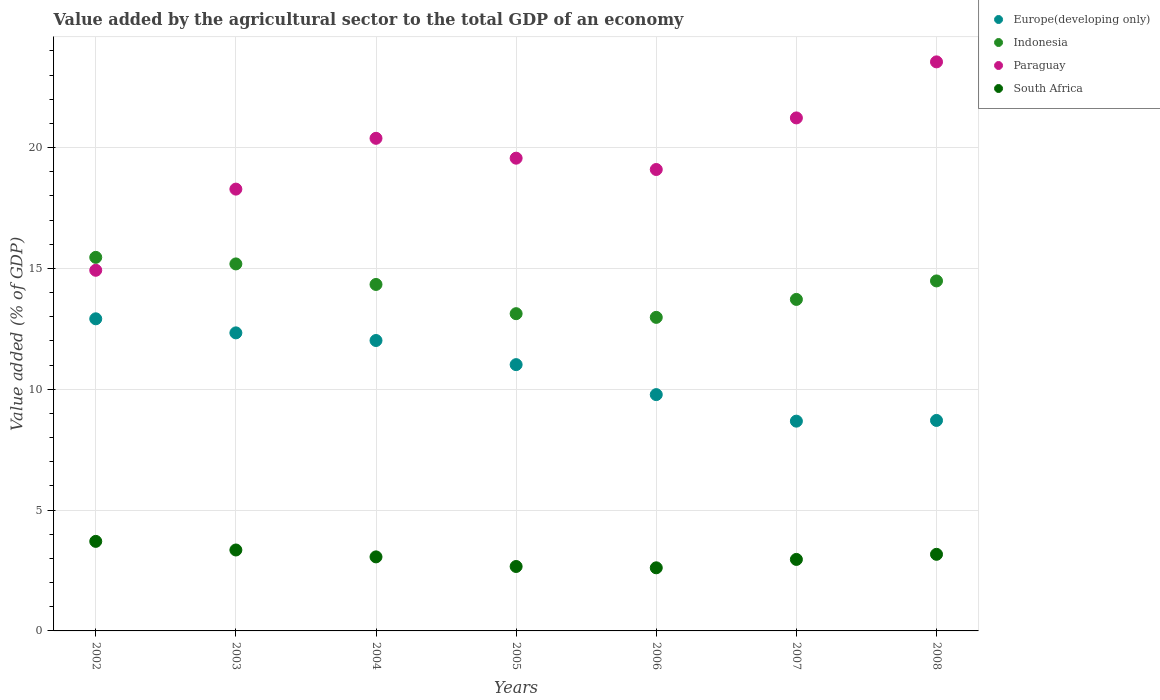How many different coloured dotlines are there?
Give a very brief answer. 4. Is the number of dotlines equal to the number of legend labels?
Your answer should be compact. Yes. What is the value added by the agricultural sector to the total GDP in Europe(developing only) in 2005?
Your answer should be compact. 11.02. Across all years, what is the maximum value added by the agricultural sector to the total GDP in South Africa?
Provide a short and direct response. 3.71. Across all years, what is the minimum value added by the agricultural sector to the total GDP in Paraguay?
Provide a short and direct response. 14.92. What is the total value added by the agricultural sector to the total GDP in Paraguay in the graph?
Your response must be concise. 137.01. What is the difference between the value added by the agricultural sector to the total GDP in Europe(developing only) in 2005 and that in 2006?
Offer a very short reply. 1.24. What is the difference between the value added by the agricultural sector to the total GDP in Indonesia in 2005 and the value added by the agricultural sector to the total GDP in Paraguay in 2008?
Your answer should be compact. -10.42. What is the average value added by the agricultural sector to the total GDP in Europe(developing only) per year?
Your answer should be very brief. 10.78. In the year 2007, what is the difference between the value added by the agricultural sector to the total GDP in South Africa and value added by the agricultural sector to the total GDP in Paraguay?
Your answer should be compact. -18.27. What is the ratio of the value added by the agricultural sector to the total GDP in South Africa in 2004 to that in 2005?
Your response must be concise. 1.15. Is the difference between the value added by the agricultural sector to the total GDP in South Africa in 2006 and 2007 greater than the difference between the value added by the agricultural sector to the total GDP in Paraguay in 2006 and 2007?
Keep it short and to the point. Yes. What is the difference between the highest and the second highest value added by the agricultural sector to the total GDP in Indonesia?
Make the answer very short. 0.27. What is the difference between the highest and the lowest value added by the agricultural sector to the total GDP in Europe(developing only)?
Provide a succinct answer. 4.23. In how many years, is the value added by the agricultural sector to the total GDP in Paraguay greater than the average value added by the agricultural sector to the total GDP in Paraguay taken over all years?
Your answer should be very brief. 3. Is it the case that in every year, the sum of the value added by the agricultural sector to the total GDP in South Africa and value added by the agricultural sector to the total GDP in Indonesia  is greater than the sum of value added by the agricultural sector to the total GDP in Europe(developing only) and value added by the agricultural sector to the total GDP in Paraguay?
Your answer should be very brief. No. Is it the case that in every year, the sum of the value added by the agricultural sector to the total GDP in Europe(developing only) and value added by the agricultural sector to the total GDP in Indonesia  is greater than the value added by the agricultural sector to the total GDP in South Africa?
Your response must be concise. Yes. Does the value added by the agricultural sector to the total GDP in South Africa monotonically increase over the years?
Offer a very short reply. No. Is the value added by the agricultural sector to the total GDP in South Africa strictly greater than the value added by the agricultural sector to the total GDP in Indonesia over the years?
Ensure brevity in your answer.  No. How many dotlines are there?
Your answer should be very brief. 4. What is the difference between two consecutive major ticks on the Y-axis?
Make the answer very short. 5. Where does the legend appear in the graph?
Keep it short and to the point. Top right. How are the legend labels stacked?
Your answer should be very brief. Vertical. What is the title of the graph?
Give a very brief answer. Value added by the agricultural sector to the total GDP of an economy. What is the label or title of the Y-axis?
Ensure brevity in your answer.  Value added (% of GDP). What is the Value added (% of GDP) in Europe(developing only) in 2002?
Provide a short and direct response. 12.91. What is the Value added (% of GDP) of Indonesia in 2002?
Offer a very short reply. 15.46. What is the Value added (% of GDP) in Paraguay in 2002?
Provide a succinct answer. 14.92. What is the Value added (% of GDP) of South Africa in 2002?
Keep it short and to the point. 3.71. What is the Value added (% of GDP) of Europe(developing only) in 2003?
Offer a terse response. 12.33. What is the Value added (% of GDP) of Indonesia in 2003?
Offer a terse response. 15.19. What is the Value added (% of GDP) of Paraguay in 2003?
Ensure brevity in your answer.  18.28. What is the Value added (% of GDP) in South Africa in 2003?
Ensure brevity in your answer.  3.35. What is the Value added (% of GDP) in Europe(developing only) in 2004?
Provide a succinct answer. 12.02. What is the Value added (% of GDP) of Indonesia in 2004?
Provide a short and direct response. 14.34. What is the Value added (% of GDP) in Paraguay in 2004?
Provide a succinct answer. 20.38. What is the Value added (% of GDP) in South Africa in 2004?
Make the answer very short. 3.06. What is the Value added (% of GDP) in Europe(developing only) in 2005?
Give a very brief answer. 11.02. What is the Value added (% of GDP) of Indonesia in 2005?
Offer a very short reply. 13.13. What is the Value added (% of GDP) in Paraguay in 2005?
Your response must be concise. 19.56. What is the Value added (% of GDP) in South Africa in 2005?
Provide a succinct answer. 2.67. What is the Value added (% of GDP) of Europe(developing only) in 2006?
Provide a succinct answer. 9.78. What is the Value added (% of GDP) in Indonesia in 2006?
Your response must be concise. 12.97. What is the Value added (% of GDP) in Paraguay in 2006?
Provide a succinct answer. 19.09. What is the Value added (% of GDP) of South Africa in 2006?
Offer a very short reply. 2.61. What is the Value added (% of GDP) of Europe(developing only) in 2007?
Keep it short and to the point. 8.68. What is the Value added (% of GDP) in Indonesia in 2007?
Your answer should be very brief. 13.72. What is the Value added (% of GDP) in Paraguay in 2007?
Provide a succinct answer. 21.23. What is the Value added (% of GDP) of South Africa in 2007?
Provide a succinct answer. 2.96. What is the Value added (% of GDP) in Europe(developing only) in 2008?
Offer a terse response. 8.71. What is the Value added (% of GDP) in Indonesia in 2008?
Your answer should be very brief. 14.48. What is the Value added (% of GDP) of Paraguay in 2008?
Ensure brevity in your answer.  23.55. What is the Value added (% of GDP) of South Africa in 2008?
Provide a short and direct response. 3.17. Across all years, what is the maximum Value added (% of GDP) of Europe(developing only)?
Make the answer very short. 12.91. Across all years, what is the maximum Value added (% of GDP) of Indonesia?
Offer a terse response. 15.46. Across all years, what is the maximum Value added (% of GDP) in Paraguay?
Offer a terse response. 23.55. Across all years, what is the maximum Value added (% of GDP) in South Africa?
Your answer should be very brief. 3.71. Across all years, what is the minimum Value added (% of GDP) of Europe(developing only)?
Give a very brief answer. 8.68. Across all years, what is the minimum Value added (% of GDP) in Indonesia?
Your answer should be very brief. 12.97. Across all years, what is the minimum Value added (% of GDP) of Paraguay?
Keep it short and to the point. 14.92. Across all years, what is the minimum Value added (% of GDP) of South Africa?
Provide a succinct answer. 2.61. What is the total Value added (% of GDP) of Europe(developing only) in the graph?
Keep it short and to the point. 75.45. What is the total Value added (% of GDP) in Indonesia in the graph?
Your answer should be compact. 99.28. What is the total Value added (% of GDP) of Paraguay in the graph?
Provide a succinct answer. 137.01. What is the total Value added (% of GDP) in South Africa in the graph?
Offer a terse response. 21.52. What is the difference between the Value added (% of GDP) of Europe(developing only) in 2002 and that in 2003?
Your answer should be very brief. 0.58. What is the difference between the Value added (% of GDP) of Indonesia in 2002 and that in 2003?
Your answer should be compact. 0.27. What is the difference between the Value added (% of GDP) of Paraguay in 2002 and that in 2003?
Your response must be concise. -3.36. What is the difference between the Value added (% of GDP) in South Africa in 2002 and that in 2003?
Keep it short and to the point. 0.36. What is the difference between the Value added (% of GDP) in Europe(developing only) in 2002 and that in 2004?
Offer a very short reply. 0.9. What is the difference between the Value added (% of GDP) in Indonesia in 2002 and that in 2004?
Provide a short and direct response. 1.12. What is the difference between the Value added (% of GDP) of Paraguay in 2002 and that in 2004?
Make the answer very short. -5.46. What is the difference between the Value added (% of GDP) of South Africa in 2002 and that in 2004?
Offer a terse response. 0.64. What is the difference between the Value added (% of GDP) of Europe(developing only) in 2002 and that in 2005?
Provide a short and direct response. 1.9. What is the difference between the Value added (% of GDP) of Indonesia in 2002 and that in 2005?
Your answer should be very brief. 2.33. What is the difference between the Value added (% of GDP) in Paraguay in 2002 and that in 2005?
Offer a terse response. -4.64. What is the difference between the Value added (% of GDP) of South Africa in 2002 and that in 2005?
Ensure brevity in your answer.  1.04. What is the difference between the Value added (% of GDP) of Europe(developing only) in 2002 and that in 2006?
Make the answer very short. 3.14. What is the difference between the Value added (% of GDP) of Indonesia in 2002 and that in 2006?
Give a very brief answer. 2.48. What is the difference between the Value added (% of GDP) of Paraguay in 2002 and that in 2006?
Offer a terse response. -4.17. What is the difference between the Value added (% of GDP) of South Africa in 2002 and that in 2006?
Keep it short and to the point. 1.09. What is the difference between the Value added (% of GDP) in Europe(developing only) in 2002 and that in 2007?
Offer a terse response. 4.23. What is the difference between the Value added (% of GDP) in Indonesia in 2002 and that in 2007?
Offer a terse response. 1.74. What is the difference between the Value added (% of GDP) of Paraguay in 2002 and that in 2007?
Your response must be concise. -6.3. What is the difference between the Value added (% of GDP) of South Africa in 2002 and that in 2007?
Keep it short and to the point. 0.75. What is the difference between the Value added (% of GDP) of Europe(developing only) in 2002 and that in 2008?
Provide a short and direct response. 4.21. What is the difference between the Value added (% of GDP) of Indonesia in 2002 and that in 2008?
Offer a terse response. 0.97. What is the difference between the Value added (% of GDP) in Paraguay in 2002 and that in 2008?
Your response must be concise. -8.62. What is the difference between the Value added (% of GDP) in South Africa in 2002 and that in 2008?
Ensure brevity in your answer.  0.54. What is the difference between the Value added (% of GDP) in Europe(developing only) in 2003 and that in 2004?
Your answer should be compact. 0.32. What is the difference between the Value added (% of GDP) in Indonesia in 2003 and that in 2004?
Ensure brevity in your answer.  0.85. What is the difference between the Value added (% of GDP) in Paraguay in 2003 and that in 2004?
Make the answer very short. -2.1. What is the difference between the Value added (% of GDP) of South Africa in 2003 and that in 2004?
Offer a terse response. 0.29. What is the difference between the Value added (% of GDP) of Europe(developing only) in 2003 and that in 2005?
Offer a terse response. 1.31. What is the difference between the Value added (% of GDP) in Indonesia in 2003 and that in 2005?
Provide a short and direct response. 2.06. What is the difference between the Value added (% of GDP) of Paraguay in 2003 and that in 2005?
Provide a succinct answer. -1.28. What is the difference between the Value added (% of GDP) in South Africa in 2003 and that in 2005?
Ensure brevity in your answer.  0.68. What is the difference between the Value added (% of GDP) of Europe(developing only) in 2003 and that in 2006?
Your answer should be very brief. 2.55. What is the difference between the Value added (% of GDP) of Indonesia in 2003 and that in 2006?
Your response must be concise. 2.21. What is the difference between the Value added (% of GDP) of Paraguay in 2003 and that in 2006?
Offer a very short reply. -0.81. What is the difference between the Value added (% of GDP) of South Africa in 2003 and that in 2006?
Make the answer very short. 0.74. What is the difference between the Value added (% of GDP) in Europe(developing only) in 2003 and that in 2007?
Offer a very short reply. 3.65. What is the difference between the Value added (% of GDP) of Indonesia in 2003 and that in 2007?
Your answer should be compact. 1.47. What is the difference between the Value added (% of GDP) of Paraguay in 2003 and that in 2007?
Your answer should be very brief. -2.95. What is the difference between the Value added (% of GDP) in South Africa in 2003 and that in 2007?
Make the answer very short. 0.39. What is the difference between the Value added (% of GDP) of Europe(developing only) in 2003 and that in 2008?
Your answer should be very brief. 3.62. What is the difference between the Value added (% of GDP) in Indonesia in 2003 and that in 2008?
Provide a short and direct response. 0.7. What is the difference between the Value added (% of GDP) of Paraguay in 2003 and that in 2008?
Provide a succinct answer. -5.26. What is the difference between the Value added (% of GDP) of South Africa in 2003 and that in 2008?
Ensure brevity in your answer.  0.18. What is the difference between the Value added (% of GDP) of Europe(developing only) in 2004 and that in 2005?
Provide a succinct answer. 1. What is the difference between the Value added (% of GDP) of Indonesia in 2004 and that in 2005?
Offer a very short reply. 1.21. What is the difference between the Value added (% of GDP) in Paraguay in 2004 and that in 2005?
Offer a terse response. 0.82. What is the difference between the Value added (% of GDP) of South Africa in 2004 and that in 2005?
Your answer should be compact. 0.4. What is the difference between the Value added (% of GDP) of Europe(developing only) in 2004 and that in 2006?
Your response must be concise. 2.24. What is the difference between the Value added (% of GDP) in Indonesia in 2004 and that in 2006?
Provide a succinct answer. 1.36. What is the difference between the Value added (% of GDP) in Paraguay in 2004 and that in 2006?
Your answer should be compact. 1.29. What is the difference between the Value added (% of GDP) in South Africa in 2004 and that in 2006?
Your response must be concise. 0.45. What is the difference between the Value added (% of GDP) of Europe(developing only) in 2004 and that in 2007?
Offer a terse response. 3.34. What is the difference between the Value added (% of GDP) of Indonesia in 2004 and that in 2007?
Give a very brief answer. 0.62. What is the difference between the Value added (% of GDP) in Paraguay in 2004 and that in 2007?
Keep it short and to the point. -0.84. What is the difference between the Value added (% of GDP) in South Africa in 2004 and that in 2007?
Make the answer very short. 0.1. What is the difference between the Value added (% of GDP) of Europe(developing only) in 2004 and that in 2008?
Your response must be concise. 3.31. What is the difference between the Value added (% of GDP) of Indonesia in 2004 and that in 2008?
Offer a terse response. -0.15. What is the difference between the Value added (% of GDP) of Paraguay in 2004 and that in 2008?
Your answer should be very brief. -3.16. What is the difference between the Value added (% of GDP) in South Africa in 2004 and that in 2008?
Make the answer very short. -0.11. What is the difference between the Value added (% of GDP) of Europe(developing only) in 2005 and that in 2006?
Your response must be concise. 1.24. What is the difference between the Value added (% of GDP) of Indonesia in 2005 and that in 2006?
Your answer should be compact. 0.15. What is the difference between the Value added (% of GDP) in Paraguay in 2005 and that in 2006?
Offer a very short reply. 0.47. What is the difference between the Value added (% of GDP) in South Africa in 2005 and that in 2006?
Offer a terse response. 0.05. What is the difference between the Value added (% of GDP) of Europe(developing only) in 2005 and that in 2007?
Ensure brevity in your answer.  2.34. What is the difference between the Value added (% of GDP) in Indonesia in 2005 and that in 2007?
Offer a terse response. -0.59. What is the difference between the Value added (% of GDP) of Paraguay in 2005 and that in 2007?
Make the answer very short. -1.67. What is the difference between the Value added (% of GDP) in South Africa in 2005 and that in 2007?
Make the answer very short. -0.29. What is the difference between the Value added (% of GDP) in Europe(developing only) in 2005 and that in 2008?
Provide a short and direct response. 2.31. What is the difference between the Value added (% of GDP) of Indonesia in 2005 and that in 2008?
Ensure brevity in your answer.  -1.36. What is the difference between the Value added (% of GDP) of Paraguay in 2005 and that in 2008?
Your answer should be very brief. -3.99. What is the difference between the Value added (% of GDP) in South Africa in 2005 and that in 2008?
Give a very brief answer. -0.5. What is the difference between the Value added (% of GDP) of Europe(developing only) in 2006 and that in 2007?
Offer a terse response. 1.1. What is the difference between the Value added (% of GDP) in Indonesia in 2006 and that in 2007?
Your answer should be compact. -0.74. What is the difference between the Value added (% of GDP) in Paraguay in 2006 and that in 2007?
Give a very brief answer. -2.13. What is the difference between the Value added (% of GDP) of South Africa in 2006 and that in 2007?
Offer a terse response. -0.35. What is the difference between the Value added (% of GDP) in Europe(developing only) in 2006 and that in 2008?
Offer a very short reply. 1.07. What is the difference between the Value added (% of GDP) of Indonesia in 2006 and that in 2008?
Keep it short and to the point. -1.51. What is the difference between the Value added (% of GDP) of Paraguay in 2006 and that in 2008?
Provide a short and direct response. -4.45. What is the difference between the Value added (% of GDP) in South Africa in 2006 and that in 2008?
Provide a short and direct response. -0.56. What is the difference between the Value added (% of GDP) of Europe(developing only) in 2007 and that in 2008?
Offer a very short reply. -0.03. What is the difference between the Value added (% of GDP) of Indonesia in 2007 and that in 2008?
Make the answer very short. -0.77. What is the difference between the Value added (% of GDP) of Paraguay in 2007 and that in 2008?
Provide a succinct answer. -2.32. What is the difference between the Value added (% of GDP) of South Africa in 2007 and that in 2008?
Offer a very short reply. -0.21. What is the difference between the Value added (% of GDP) in Europe(developing only) in 2002 and the Value added (% of GDP) in Indonesia in 2003?
Keep it short and to the point. -2.27. What is the difference between the Value added (% of GDP) in Europe(developing only) in 2002 and the Value added (% of GDP) in Paraguay in 2003?
Ensure brevity in your answer.  -5.37. What is the difference between the Value added (% of GDP) of Europe(developing only) in 2002 and the Value added (% of GDP) of South Africa in 2003?
Ensure brevity in your answer.  9.57. What is the difference between the Value added (% of GDP) of Indonesia in 2002 and the Value added (% of GDP) of Paraguay in 2003?
Ensure brevity in your answer.  -2.82. What is the difference between the Value added (% of GDP) of Indonesia in 2002 and the Value added (% of GDP) of South Africa in 2003?
Provide a succinct answer. 12.11. What is the difference between the Value added (% of GDP) of Paraguay in 2002 and the Value added (% of GDP) of South Africa in 2003?
Ensure brevity in your answer.  11.57. What is the difference between the Value added (% of GDP) of Europe(developing only) in 2002 and the Value added (% of GDP) of Indonesia in 2004?
Offer a very short reply. -1.42. What is the difference between the Value added (% of GDP) in Europe(developing only) in 2002 and the Value added (% of GDP) in Paraguay in 2004?
Give a very brief answer. -7.47. What is the difference between the Value added (% of GDP) of Europe(developing only) in 2002 and the Value added (% of GDP) of South Africa in 2004?
Your answer should be compact. 9.85. What is the difference between the Value added (% of GDP) of Indonesia in 2002 and the Value added (% of GDP) of Paraguay in 2004?
Give a very brief answer. -4.93. What is the difference between the Value added (% of GDP) of Indonesia in 2002 and the Value added (% of GDP) of South Africa in 2004?
Offer a very short reply. 12.39. What is the difference between the Value added (% of GDP) in Paraguay in 2002 and the Value added (% of GDP) in South Africa in 2004?
Make the answer very short. 11.86. What is the difference between the Value added (% of GDP) of Europe(developing only) in 2002 and the Value added (% of GDP) of Indonesia in 2005?
Offer a terse response. -0.21. What is the difference between the Value added (% of GDP) in Europe(developing only) in 2002 and the Value added (% of GDP) in Paraguay in 2005?
Your answer should be very brief. -6.65. What is the difference between the Value added (% of GDP) in Europe(developing only) in 2002 and the Value added (% of GDP) in South Africa in 2005?
Provide a succinct answer. 10.25. What is the difference between the Value added (% of GDP) of Indonesia in 2002 and the Value added (% of GDP) of Paraguay in 2005?
Offer a very short reply. -4.1. What is the difference between the Value added (% of GDP) in Indonesia in 2002 and the Value added (% of GDP) in South Africa in 2005?
Provide a succinct answer. 12.79. What is the difference between the Value added (% of GDP) of Paraguay in 2002 and the Value added (% of GDP) of South Africa in 2005?
Keep it short and to the point. 12.26. What is the difference between the Value added (% of GDP) of Europe(developing only) in 2002 and the Value added (% of GDP) of Indonesia in 2006?
Ensure brevity in your answer.  -0.06. What is the difference between the Value added (% of GDP) in Europe(developing only) in 2002 and the Value added (% of GDP) in Paraguay in 2006?
Your answer should be compact. -6.18. What is the difference between the Value added (% of GDP) of Europe(developing only) in 2002 and the Value added (% of GDP) of South Africa in 2006?
Your answer should be very brief. 10.3. What is the difference between the Value added (% of GDP) in Indonesia in 2002 and the Value added (% of GDP) in Paraguay in 2006?
Offer a terse response. -3.64. What is the difference between the Value added (% of GDP) in Indonesia in 2002 and the Value added (% of GDP) in South Africa in 2006?
Offer a terse response. 12.85. What is the difference between the Value added (% of GDP) of Paraguay in 2002 and the Value added (% of GDP) of South Africa in 2006?
Your response must be concise. 12.31. What is the difference between the Value added (% of GDP) in Europe(developing only) in 2002 and the Value added (% of GDP) in Indonesia in 2007?
Your answer should be compact. -0.8. What is the difference between the Value added (% of GDP) of Europe(developing only) in 2002 and the Value added (% of GDP) of Paraguay in 2007?
Keep it short and to the point. -8.31. What is the difference between the Value added (% of GDP) in Europe(developing only) in 2002 and the Value added (% of GDP) in South Africa in 2007?
Your answer should be compact. 9.96. What is the difference between the Value added (% of GDP) in Indonesia in 2002 and the Value added (% of GDP) in Paraguay in 2007?
Your response must be concise. -5.77. What is the difference between the Value added (% of GDP) of Indonesia in 2002 and the Value added (% of GDP) of South Africa in 2007?
Ensure brevity in your answer.  12.5. What is the difference between the Value added (% of GDP) in Paraguay in 2002 and the Value added (% of GDP) in South Africa in 2007?
Offer a very short reply. 11.96. What is the difference between the Value added (% of GDP) of Europe(developing only) in 2002 and the Value added (% of GDP) of Indonesia in 2008?
Your answer should be compact. -1.57. What is the difference between the Value added (% of GDP) in Europe(developing only) in 2002 and the Value added (% of GDP) in Paraguay in 2008?
Offer a very short reply. -10.63. What is the difference between the Value added (% of GDP) of Europe(developing only) in 2002 and the Value added (% of GDP) of South Africa in 2008?
Your response must be concise. 9.74. What is the difference between the Value added (% of GDP) in Indonesia in 2002 and the Value added (% of GDP) in Paraguay in 2008?
Ensure brevity in your answer.  -8.09. What is the difference between the Value added (% of GDP) of Indonesia in 2002 and the Value added (% of GDP) of South Africa in 2008?
Provide a short and direct response. 12.29. What is the difference between the Value added (% of GDP) in Paraguay in 2002 and the Value added (% of GDP) in South Africa in 2008?
Offer a terse response. 11.75. What is the difference between the Value added (% of GDP) in Europe(developing only) in 2003 and the Value added (% of GDP) in Indonesia in 2004?
Your answer should be compact. -2. What is the difference between the Value added (% of GDP) in Europe(developing only) in 2003 and the Value added (% of GDP) in Paraguay in 2004?
Make the answer very short. -8.05. What is the difference between the Value added (% of GDP) in Europe(developing only) in 2003 and the Value added (% of GDP) in South Africa in 2004?
Your answer should be very brief. 9.27. What is the difference between the Value added (% of GDP) of Indonesia in 2003 and the Value added (% of GDP) of Paraguay in 2004?
Offer a terse response. -5.2. What is the difference between the Value added (% of GDP) of Indonesia in 2003 and the Value added (% of GDP) of South Africa in 2004?
Provide a succinct answer. 12.12. What is the difference between the Value added (% of GDP) in Paraguay in 2003 and the Value added (% of GDP) in South Africa in 2004?
Make the answer very short. 15.22. What is the difference between the Value added (% of GDP) in Europe(developing only) in 2003 and the Value added (% of GDP) in Indonesia in 2005?
Make the answer very short. -0.79. What is the difference between the Value added (% of GDP) in Europe(developing only) in 2003 and the Value added (% of GDP) in Paraguay in 2005?
Give a very brief answer. -7.23. What is the difference between the Value added (% of GDP) of Europe(developing only) in 2003 and the Value added (% of GDP) of South Africa in 2005?
Offer a very short reply. 9.67. What is the difference between the Value added (% of GDP) in Indonesia in 2003 and the Value added (% of GDP) in Paraguay in 2005?
Give a very brief answer. -4.38. What is the difference between the Value added (% of GDP) of Indonesia in 2003 and the Value added (% of GDP) of South Africa in 2005?
Provide a short and direct response. 12.52. What is the difference between the Value added (% of GDP) in Paraguay in 2003 and the Value added (% of GDP) in South Africa in 2005?
Ensure brevity in your answer.  15.61. What is the difference between the Value added (% of GDP) in Europe(developing only) in 2003 and the Value added (% of GDP) in Indonesia in 2006?
Give a very brief answer. -0.64. What is the difference between the Value added (% of GDP) of Europe(developing only) in 2003 and the Value added (% of GDP) of Paraguay in 2006?
Your answer should be very brief. -6.76. What is the difference between the Value added (% of GDP) in Europe(developing only) in 2003 and the Value added (% of GDP) in South Africa in 2006?
Provide a succinct answer. 9.72. What is the difference between the Value added (% of GDP) in Indonesia in 2003 and the Value added (% of GDP) in Paraguay in 2006?
Make the answer very short. -3.91. What is the difference between the Value added (% of GDP) of Indonesia in 2003 and the Value added (% of GDP) of South Africa in 2006?
Provide a short and direct response. 12.57. What is the difference between the Value added (% of GDP) of Paraguay in 2003 and the Value added (% of GDP) of South Africa in 2006?
Your answer should be very brief. 15.67. What is the difference between the Value added (% of GDP) in Europe(developing only) in 2003 and the Value added (% of GDP) in Indonesia in 2007?
Offer a terse response. -1.38. What is the difference between the Value added (% of GDP) of Europe(developing only) in 2003 and the Value added (% of GDP) of Paraguay in 2007?
Your response must be concise. -8.89. What is the difference between the Value added (% of GDP) in Europe(developing only) in 2003 and the Value added (% of GDP) in South Africa in 2007?
Offer a terse response. 9.37. What is the difference between the Value added (% of GDP) of Indonesia in 2003 and the Value added (% of GDP) of Paraguay in 2007?
Provide a succinct answer. -6.04. What is the difference between the Value added (% of GDP) in Indonesia in 2003 and the Value added (% of GDP) in South Africa in 2007?
Your response must be concise. 12.23. What is the difference between the Value added (% of GDP) in Paraguay in 2003 and the Value added (% of GDP) in South Africa in 2007?
Offer a very short reply. 15.32. What is the difference between the Value added (% of GDP) in Europe(developing only) in 2003 and the Value added (% of GDP) in Indonesia in 2008?
Give a very brief answer. -2.15. What is the difference between the Value added (% of GDP) in Europe(developing only) in 2003 and the Value added (% of GDP) in Paraguay in 2008?
Ensure brevity in your answer.  -11.21. What is the difference between the Value added (% of GDP) in Europe(developing only) in 2003 and the Value added (% of GDP) in South Africa in 2008?
Provide a short and direct response. 9.16. What is the difference between the Value added (% of GDP) of Indonesia in 2003 and the Value added (% of GDP) of Paraguay in 2008?
Keep it short and to the point. -8.36. What is the difference between the Value added (% of GDP) in Indonesia in 2003 and the Value added (% of GDP) in South Africa in 2008?
Ensure brevity in your answer.  12.02. What is the difference between the Value added (% of GDP) in Paraguay in 2003 and the Value added (% of GDP) in South Africa in 2008?
Your answer should be very brief. 15.11. What is the difference between the Value added (% of GDP) of Europe(developing only) in 2004 and the Value added (% of GDP) of Indonesia in 2005?
Keep it short and to the point. -1.11. What is the difference between the Value added (% of GDP) of Europe(developing only) in 2004 and the Value added (% of GDP) of Paraguay in 2005?
Ensure brevity in your answer.  -7.54. What is the difference between the Value added (% of GDP) in Europe(developing only) in 2004 and the Value added (% of GDP) in South Africa in 2005?
Your answer should be very brief. 9.35. What is the difference between the Value added (% of GDP) in Indonesia in 2004 and the Value added (% of GDP) in Paraguay in 2005?
Your answer should be compact. -5.22. What is the difference between the Value added (% of GDP) in Indonesia in 2004 and the Value added (% of GDP) in South Africa in 2005?
Offer a terse response. 11.67. What is the difference between the Value added (% of GDP) of Paraguay in 2004 and the Value added (% of GDP) of South Africa in 2005?
Your answer should be compact. 17.72. What is the difference between the Value added (% of GDP) of Europe(developing only) in 2004 and the Value added (% of GDP) of Indonesia in 2006?
Offer a very short reply. -0.96. What is the difference between the Value added (% of GDP) in Europe(developing only) in 2004 and the Value added (% of GDP) in Paraguay in 2006?
Offer a terse response. -7.08. What is the difference between the Value added (% of GDP) of Europe(developing only) in 2004 and the Value added (% of GDP) of South Africa in 2006?
Your answer should be compact. 9.41. What is the difference between the Value added (% of GDP) of Indonesia in 2004 and the Value added (% of GDP) of Paraguay in 2006?
Your answer should be compact. -4.76. What is the difference between the Value added (% of GDP) in Indonesia in 2004 and the Value added (% of GDP) in South Africa in 2006?
Make the answer very short. 11.72. What is the difference between the Value added (% of GDP) in Paraguay in 2004 and the Value added (% of GDP) in South Africa in 2006?
Offer a very short reply. 17.77. What is the difference between the Value added (% of GDP) in Europe(developing only) in 2004 and the Value added (% of GDP) in Indonesia in 2007?
Your answer should be compact. -1.7. What is the difference between the Value added (% of GDP) in Europe(developing only) in 2004 and the Value added (% of GDP) in Paraguay in 2007?
Provide a succinct answer. -9.21. What is the difference between the Value added (% of GDP) in Europe(developing only) in 2004 and the Value added (% of GDP) in South Africa in 2007?
Provide a succinct answer. 9.06. What is the difference between the Value added (% of GDP) of Indonesia in 2004 and the Value added (% of GDP) of Paraguay in 2007?
Your answer should be compact. -6.89. What is the difference between the Value added (% of GDP) of Indonesia in 2004 and the Value added (% of GDP) of South Africa in 2007?
Your response must be concise. 11.38. What is the difference between the Value added (% of GDP) of Paraguay in 2004 and the Value added (% of GDP) of South Africa in 2007?
Make the answer very short. 17.42. What is the difference between the Value added (% of GDP) of Europe(developing only) in 2004 and the Value added (% of GDP) of Indonesia in 2008?
Offer a terse response. -2.47. What is the difference between the Value added (% of GDP) of Europe(developing only) in 2004 and the Value added (% of GDP) of Paraguay in 2008?
Offer a very short reply. -11.53. What is the difference between the Value added (% of GDP) of Europe(developing only) in 2004 and the Value added (% of GDP) of South Africa in 2008?
Your answer should be compact. 8.85. What is the difference between the Value added (% of GDP) in Indonesia in 2004 and the Value added (% of GDP) in Paraguay in 2008?
Offer a very short reply. -9.21. What is the difference between the Value added (% of GDP) in Indonesia in 2004 and the Value added (% of GDP) in South Africa in 2008?
Make the answer very short. 11.17. What is the difference between the Value added (% of GDP) of Paraguay in 2004 and the Value added (% of GDP) of South Africa in 2008?
Your response must be concise. 17.21. What is the difference between the Value added (% of GDP) in Europe(developing only) in 2005 and the Value added (% of GDP) in Indonesia in 2006?
Provide a short and direct response. -1.96. What is the difference between the Value added (% of GDP) of Europe(developing only) in 2005 and the Value added (% of GDP) of Paraguay in 2006?
Give a very brief answer. -8.07. What is the difference between the Value added (% of GDP) of Europe(developing only) in 2005 and the Value added (% of GDP) of South Africa in 2006?
Offer a very short reply. 8.41. What is the difference between the Value added (% of GDP) of Indonesia in 2005 and the Value added (% of GDP) of Paraguay in 2006?
Your answer should be very brief. -5.97. What is the difference between the Value added (% of GDP) in Indonesia in 2005 and the Value added (% of GDP) in South Africa in 2006?
Ensure brevity in your answer.  10.52. What is the difference between the Value added (% of GDP) of Paraguay in 2005 and the Value added (% of GDP) of South Africa in 2006?
Your response must be concise. 16.95. What is the difference between the Value added (% of GDP) in Europe(developing only) in 2005 and the Value added (% of GDP) in Indonesia in 2007?
Ensure brevity in your answer.  -2.7. What is the difference between the Value added (% of GDP) in Europe(developing only) in 2005 and the Value added (% of GDP) in Paraguay in 2007?
Ensure brevity in your answer.  -10.21. What is the difference between the Value added (% of GDP) in Europe(developing only) in 2005 and the Value added (% of GDP) in South Africa in 2007?
Offer a terse response. 8.06. What is the difference between the Value added (% of GDP) in Indonesia in 2005 and the Value added (% of GDP) in Paraguay in 2007?
Your response must be concise. -8.1. What is the difference between the Value added (% of GDP) in Indonesia in 2005 and the Value added (% of GDP) in South Africa in 2007?
Your answer should be compact. 10.17. What is the difference between the Value added (% of GDP) of Paraguay in 2005 and the Value added (% of GDP) of South Africa in 2007?
Make the answer very short. 16.6. What is the difference between the Value added (% of GDP) of Europe(developing only) in 2005 and the Value added (% of GDP) of Indonesia in 2008?
Provide a succinct answer. -3.46. What is the difference between the Value added (% of GDP) of Europe(developing only) in 2005 and the Value added (% of GDP) of Paraguay in 2008?
Provide a short and direct response. -12.53. What is the difference between the Value added (% of GDP) in Europe(developing only) in 2005 and the Value added (% of GDP) in South Africa in 2008?
Your response must be concise. 7.85. What is the difference between the Value added (% of GDP) in Indonesia in 2005 and the Value added (% of GDP) in Paraguay in 2008?
Give a very brief answer. -10.42. What is the difference between the Value added (% of GDP) of Indonesia in 2005 and the Value added (% of GDP) of South Africa in 2008?
Offer a terse response. 9.96. What is the difference between the Value added (% of GDP) in Paraguay in 2005 and the Value added (% of GDP) in South Africa in 2008?
Offer a terse response. 16.39. What is the difference between the Value added (% of GDP) in Europe(developing only) in 2006 and the Value added (% of GDP) in Indonesia in 2007?
Your response must be concise. -3.94. What is the difference between the Value added (% of GDP) of Europe(developing only) in 2006 and the Value added (% of GDP) of Paraguay in 2007?
Provide a succinct answer. -11.45. What is the difference between the Value added (% of GDP) in Europe(developing only) in 2006 and the Value added (% of GDP) in South Africa in 2007?
Offer a very short reply. 6.82. What is the difference between the Value added (% of GDP) of Indonesia in 2006 and the Value added (% of GDP) of Paraguay in 2007?
Provide a succinct answer. -8.25. What is the difference between the Value added (% of GDP) in Indonesia in 2006 and the Value added (% of GDP) in South Africa in 2007?
Offer a terse response. 10.02. What is the difference between the Value added (% of GDP) in Paraguay in 2006 and the Value added (% of GDP) in South Africa in 2007?
Offer a terse response. 16.13. What is the difference between the Value added (% of GDP) in Europe(developing only) in 2006 and the Value added (% of GDP) in Indonesia in 2008?
Your answer should be compact. -4.7. What is the difference between the Value added (% of GDP) in Europe(developing only) in 2006 and the Value added (% of GDP) in Paraguay in 2008?
Offer a terse response. -13.77. What is the difference between the Value added (% of GDP) in Europe(developing only) in 2006 and the Value added (% of GDP) in South Africa in 2008?
Give a very brief answer. 6.61. What is the difference between the Value added (% of GDP) of Indonesia in 2006 and the Value added (% of GDP) of Paraguay in 2008?
Offer a terse response. -10.57. What is the difference between the Value added (% of GDP) in Indonesia in 2006 and the Value added (% of GDP) in South Africa in 2008?
Provide a succinct answer. 9.8. What is the difference between the Value added (% of GDP) of Paraguay in 2006 and the Value added (% of GDP) of South Africa in 2008?
Keep it short and to the point. 15.92. What is the difference between the Value added (% of GDP) of Europe(developing only) in 2007 and the Value added (% of GDP) of Indonesia in 2008?
Your response must be concise. -5.8. What is the difference between the Value added (% of GDP) in Europe(developing only) in 2007 and the Value added (% of GDP) in Paraguay in 2008?
Ensure brevity in your answer.  -14.87. What is the difference between the Value added (% of GDP) in Europe(developing only) in 2007 and the Value added (% of GDP) in South Africa in 2008?
Ensure brevity in your answer.  5.51. What is the difference between the Value added (% of GDP) of Indonesia in 2007 and the Value added (% of GDP) of Paraguay in 2008?
Offer a very short reply. -9.83. What is the difference between the Value added (% of GDP) of Indonesia in 2007 and the Value added (% of GDP) of South Africa in 2008?
Your answer should be very brief. 10.55. What is the difference between the Value added (% of GDP) of Paraguay in 2007 and the Value added (% of GDP) of South Africa in 2008?
Give a very brief answer. 18.06. What is the average Value added (% of GDP) in Europe(developing only) per year?
Give a very brief answer. 10.78. What is the average Value added (% of GDP) of Indonesia per year?
Offer a terse response. 14.18. What is the average Value added (% of GDP) of Paraguay per year?
Keep it short and to the point. 19.57. What is the average Value added (% of GDP) of South Africa per year?
Provide a succinct answer. 3.07. In the year 2002, what is the difference between the Value added (% of GDP) in Europe(developing only) and Value added (% of GDP) in Indonesia?
Your answer should be compact. -2.54. In the year 2002, what is the difference between the Value added (% of GDP) in Europe(developing only) and Value added (% of GDP) in Paraguay?
Make the answer very short. -2.01. In the year 2002, what is the difference between the Value added (% of GDP) of Europe(developing only) and Value added (% of GDP) of South Africa?
Your answer should be compact. 9.21. In the year 2002, what is the difference between the Value added (% of GDP) in Indonesia and Value added (% of GDP) in Paraguay?
Your answer should be compact. 0.53. In the year 2002, what is the difference between the Value added (% of GDP) of Indonesia and Value added (% of GDP) of South Africa?
Provide a short and direct response. 11.75. In the year 2002, what is the difference between the Value added (% of GDP) in Paraguay and Value added (% of GDP) in South Africa?
Keep it short and to the point. 11.22. In the year 2003, what is the difference between the Value added (% of GDP) in Europe(developing only) and Value added (% of GDP) in Indonesia?
Your response must be concise. -2.85. In the year 2003, what is the difference between the Value added (% of GDP) in Europe(developing only) and Value added (% of GDP) in Paraguay?
Ensure brevity in your answer.  -5.95. In the year 2003, what is the difference between the Value added (% of GDP) in Europe(developing only) and Value added (% of GDP) in South Africa?
Keep it short and to the point. 8.98. In the year 2003, what is the difference between the Value added (% of GDP) of Indonesia and Value added (% of GDP) of Paraguay?
Make the answer very short. -3.1. In the year 2003, what is the difference between the Value added (% of GDP) of Indonesia and Value added (% of GDP) of South Africa?
Ensure brevity in your answer.  11.84. In the year 2003, what is the difference between the Value added (% of GDP) in Paraguay and Value added (% of GDP) in South Africa?
Make the answer very short. 14.93. In the year 2004, what is the difference between the Value added (% of GDP) of Europe(developing only) and Value added (% of GDP) of Indonesia?
Your answer should be compact. -2.32. In the year 2004, what is the difference between the Value added (% of GDP) in Europe(developing only) and Value added (% of GDP) in Paraguay?
Ensure brevity in your answer.  -8.37. In the year 2004, what is the difference between the Value added (% of GDP) in Europe(developing only) and Value added (% of GDP) in South Africa?
Keep it short and to the point. 8.95. In the year 2004, what is the difference between the Value added (% of GDP) of Indonesia and Value added (% of GDP) of Paraguay?
Make the answer very short. -6.05. In the year 2004, what is the difference between the Value added (% of GDP) of Indonesia and Value added (% of GDP) of South Africa?
Provide a succinct answer. 11.27. In the year 2004, what is the difference between the Value added (% of GDP) of Paraguay and Value added (% of GDP) of South Africa?
Provide a succinct answer. 17.32. In the year 2005, what is the difference between the Value added (% of GDP) of Europe(developing only) and Value added (% of GDP) of Indonesia?
Ensure brevity in your answer.  -2.11. In the year 2005, what is the difference between the Value added (% of GDP) of Europe(developing only) and Value added (% of GDP) of Paraguay?
Give a very brief answer. -8.54. In the year 2005, what is the difference between the Value added (% of GDP) of Europe(developing only) and Value added (% of GDP) of South Africa?
Provide a succinct answer. 8.35. In the year 2005, what is the difference between the Value added (% of GDP) in Indonesia and Value added (% of GDP) in Paraguay?
Your response must be concise. -6.43. In the year 2005, what is the difference between the Value added (% of GDP) of Indonesia and Value added (% of GDP) of South Africa?
Make the answer very short. 10.46. In the year 2005, what is the difference between the Value added (% of GDP) of Paraguay and Value added (% of GDP) of South Africa?
Offer a terse response. 16.89. In the year 2006, what is the difference between the Value added (% of GDP) in Europe(developing only) and Value added (% of GDP) in Indonesia?
Ensure brevity in your answer.  -3.2. In the year 2006, what is the difference between the Value added (% of GDP) in Europe(developing only) and Value added (% of GDP) in Paraguay?
Your answer should be compact. -9.31. In the year 2006, what is the difference between the Value added (% of GDP) of Europe(developing only) and Value added (% of GDP) of South Africa?
Ensure brevity in your answer.  7.17. In the year 2006, what is the difference between the Value added (% of GDP) in Indonesia and Value added (% of GDP) in Paraguay?
Offer a terse response. -6.12. In the year 2006, what is the difference between the Value added (% of GDP) in Indonesia and Value added (% of GDP) in South Africa?
Keep it short and to the point. 10.36. In the year 2006, what is the difference between the Value added (% of GDP) of Paraguay and Value added (% of GDP) of South Africa?
Your response must be concise. 16.48. In the year 2007, what is the difference between the Value added (% of GDP) of Europe(developing only) and Value added (% of GDP) of Indonesia?
Your answer should be compact. -5.04. In the year 2007, what is the difference between the Value added (% of GDP) in Europe(developing only) and Value added (% of GDP) in Paraguay?
Make the answer very short. -12.55. In the year 2007, what is the difference between the Value added (% of GDP) of Europe(developing only) and Value added (% of GDP) of South Africa?
Provide a short and direct response. 5.72. In the year 2007, what is the difference between the Value added (% of GDP) of Indonesia and Value added (% of GDP) of Paraguay?
Offer a terse response. -7.51. In the year 2007, what is the difference between the Value added (% of GDP) in Indonesia and Value added (% of GDP) in South Africa?
Offer a very short reply. 10.76. In the year 2007, what is the difference between the Value added (% of GDP) in Paraguay and Value added (% of GDP) in South Africa?
Offer a very short reply. 18.27. In the year 2008, what is the difference between the Value added (% of GDP) in Europe(developing only) and Value added (% of GDP) in Indonesia?
Offer a very short reply. -5.77. In the year 2008, what is the difference between the Value added (% of GDP) of Europe(developing only) and Value added (% of GDP) of Paraguay?
Your answer should be very brief. -14.84. In the year 2008, what is the difference between the Value added (% of GDP) in Europe(developing only) and Value added (% of GDP) in South Africa?
Offer a very short reply. 5.54. In the year 2008, what is the difference between the Value added (% of GDP) in Indonesia and Value added (% of GDP) in Paraguay?
Your response must be concise. -9.06. In the year 2008, what is the difference between the Value added (% of GDP) in Indonesia and Value added (% of GDP) in South Africa?
Provide a short and direct response. 11.31. In the year 2008, what is the difference between the Value added (% of GDP) of Paraguay and Value added (% of GDP) of South Africa?
Offer a terse response. 20.38. What is the ratio of the Value added (% of GDP) of Europe(developing only) in 2002 to that in 2003?
Your answer should be very brief. 1.05. What is the ratio of the Value added (% of GDP) in Indonesia in 2002 to that in 2003?
Your answer should be compact. 1.02. What is the ratio of the Value added (% of GDP) of Paraguay in 2002 to that in 2003?
Offer a very short reply. 0.82. What is the ratio of the Value added (% of GDP) in South Africa in 2002 to that in 2003?
Provide a short and direct response. 1.11. What is the ratio of the Value added (% of GDP) in Europe(developing only) in 2002 to that in 2004?
Provide a succinct answer. 1.07. What is the ratio of the Value added (% of GDP) of Indonesia in 2002 to that in 2004?
Offer a terse response. 1.08. What is the ratio of the Value added (% of GDP) of Paraguay in 2002 to that in 2004?
Make the answer very short. 0.73. What is the ratio of the Value added (% of GDP) of South Africa in 2002 to that in 2004?
Offer a very short reply. 1.21. What is the ratio of the Value added (% of GDP) of Europe(developing only) in 2002 to that in 2005?
Your answer should be compact. 1.17. What is the ratio of the Value added (% of GDP) in Indonesia in 2002 to that in 2005?
Offer a terse response. 1.18. What is the ratio of the Value added (% of GDP) in Paraguay in 2002 to that in 2005?
Offer a terse response. 0.76. What is the ratio of the Value added (% of GDP) of South Africa in 2002 to that in 2005?
Provide a succinct answer. 1.39. What is the ratio of the Value added (% of GDP) in Europe(developing only) in 2002 to that in 2006?
Your response must be concise. 1.32. What is the ratio of the Value added (% of GDP) of Indonesia in 2002 to that in 2006?
Offer a terse response. 1.19. What is the ratio of the Value added (% of GDP) of Paraguay in 2002 to that in 2006?
Your response must be concise. 0.78. What is the ratio of the Value added (% of GDP) in South Africa in 2002 to that in 2006?
Your answer should be very brief. 1.42. What is the ratio of the Value added (% of GDP) of Europe(developing only) in 2002 to that in 2007?
Keep it short and to the point. 1.49. What is the ratio of the Value added (% of GDP) of Indonesia in 2002 to that in 2007?
Offer a terse response. 1.13. What is the ratio of the Value added (% of GDP) in Paraguay in 2002 to that in 2007?
Provide a succinct answer. 0.7. What is the ratio of the Value added (% of GDP) in South Africa in 2002 to that in 2007?
Offer a terse response. 1.25. What is the ratio of the Value added (% of GDP) in Europe(developing only) in 2002 to that in 2008?
Provide a short and direct response. 1.48. What is the ratio of the Value added (% of GDP) of Indonesia in 2002 to that in 2008?
Provide a short and direct response. 1.07. What is the ratio of the Value added (% of GDP) of Paraguay in 2002 to that in 2008?
Offer a terse response. 0.63. What is the ratio of the Value added (% of GDP) in South Africa in 2002 to that in 2008?
Make the answer very short. 1.17. What is the ratio of the Value added (% of GDP) of Europe(developing only) in 2003 to that in 2004?
Your response must be concise. 1.03. What is the ratio of the Value added (% of GDP) of Indonesia in 2003 to that in 2004?
Your answer should be very brief. 1.06. What is the ratio of the Value added (% of GDP) of Paraguay in 2003 to that in 2004?
Offer a terse response. 0.9. What is the ratio of the Value added (% of GDP) of South Africa in 2003 to that in 2004?
Your answer should be compact. 1.09. What is the ratio of the Value added (% of GDP) in Europe(developing only) in 2003 to that in 2005?
Offer a terse response. 1.12. What is the ratio of the Value added (% of GDP) in Indonesia in 2003 to that in 2005?
Your answer should be compact. 1.16. What is the ratio of the Value added (% of GDP) of Paraguay in 2003 to that in 2005?
Make the answer very short. 0.93. What is the ratio of the Value added (% of GDP) of South Africa in 2003 to that in 2005?
Your answer should be very brief. 1.26. What is the ratio of the Value added (% of GDP) in Europe(developing only) in 2003 to that in 2006?
Give a very brief answer. 1.26. What is the ratio of the Value added (% of GDP) of Indonesia in 2003 to that in 2006?
Provide a succinct answer. 1.17. What is the ratio of the Value added (% of GDP) of Paraguay in 2003 to that in 2006?
Give a very brief answer. 0.96. What is the ratio of the Value added (% of GDP) in South Africa in 2003 to that in 2006?
Make the answer very short. 1.28. What is the ratio of the Value added (% of GDP) in Europe(developing only) in 2003 to that in 2007?
Ensure brevity in your answer.  1.42. What is the ratio of the Value added (% of GDP) of Indonesia in 2003 to that in 2007?
Make the answer very short. 1.11. What is the ratio of the Value added (% of GDP) of Paraguay in 2003 to that in 2007?
Provide a short and direct response. 0.86. What is the ratio of the Value added (% of GDP) of South Africa in 2003 to that in 2007?
Offer a terse response. 1.13. What is the ratio of the Value added (% of GDP) in Europe(developing only) in 2003 to that in 2008?
Keep it short and to the point. 1.42. What is the ratio of the Value added (% of GDP) in Indonesia in 2003 to that in 2008?
Your response must be concise. 1.05. What is the ratio of the Value added (% of GDP) in Paraguay in 2003 to that in 2008?
Ensure brevity in your answer.  0.78. What is the ratio of the Value added (% of GDP) in South Africa in 2003 to that in 2008?
Ensure brevity in your answer.  1.06. What is the ratio of the Value added (% of GDP) of Europe(developing only) in 2004 to that in 2005?
Make the answer very short. 1.09. What is the ratio of the Value added (% of GDP) of Indonesia in 2004 to that in 2005?
Offer a very short reply. 1.09. What is the ratio of the Value added (% of GDP) in Paraguay in 2004 to that in 2005?
Your answer should be compact. 1.04. What is the ratio of the Value added (% of GDP) in South Africa in 2004 to that in 2005?
Your answer should be compact. 1.15. What is the ratio of the Value added (% of GDP) of Europe(developing only) in 2004 to that in 2006?
Provide a short and direct response. 1.23. What is the ratio of the Value added (% of GDP) of Indonesia in 2004 to that in 2006?
Offer a very short reply. 1.1. What is the ratio of the Value added (% of GDP) in Paraguay in 2004 to that in 2006?
Offer a very short reply. 1.07. What is the ratio of the Value added (% of GDP) in South Africa in 2004 to that in 2006?
Give a very brief answer. 1.17. What is the ratio of the Value added (% of GDP) in Europe(developing only) in 2004 to that in 2007?
Ensure brevity in your answer.  1.38. What is the ratio of the Value added (% of GDP) in Indonesia in 2004 to that in 2007?
Provide a short and direct response. 1.05. What is the ratio of the Value added (% of GDP) in Paraguay in 2004 to that in 2007?
Provide a succinct answer. 0.96. What is the ratio of the Value added (% of GDP) of South Africa in 2004 to that in 2007?
Your response must be concise. 1.04. What is the ratio of the Value added (% of GDP) in Europe(developing only) in 2004 to that in 2008?
Make the answer very short. 1.38. What is the ratio of the Value added (% of GDP) in Indonesia in 2004 to that in 2008?
Make the answer very short. 0.99. What is the ratio of the Value added (% of GDP) of Paraguay in 2004 to that in 2008?
Your response must be concise. 0.87. What is the ratio of the Value added (% of GDP) in South Africa in 2004 to that in 2008?
Give a very brief answer. 0.97. What is the ratio of the Value added (% of GDP) in Europe(developing only) in 2005 to that in 2006?
Your answer should be very brief. 1.13. What is the ratio of the Value added (% of GDP) in Indonesia in 2005 to that in 2006?
Offer a terse response. 1.01. What is the ratio of the Value added (% of GDP) of Paraguay in 2005 to that in 2006?
Your answer should be very brief. 1.02. What is the ratio of the Value added (% of GDP) of Europe(developing only) in 2005 to that in 2007?
Keep it short and to the point. 1.27. What is the ratio of the Value added (% of GDP) of Indonesia in 2005 to that in 2007?
Your answer should be very brief. 0.96. What is the ratio of the Value added (% of GDP) of Paraguay in 2005 to that in 2007?
Your response must be concise. 0.92. What is the ratio of the Value added (% of GDP) of South Africa in 2005 to that in 2007?
Your answer should be compact. 0.9. What is the ratio of the Value added (% of GDP) in Europe(developing only) in 2005 to that in 2008?
Provide a succinct answer. 1.27. What is the ratio of the Value added (% of GDP) of Indonesia in 2005 to that in 2008?
Your answer should be compact. 0.91. What is the ratio of the Value added (% of GDP) of Paraguay in 2005 to that in 2008?
Your answer should be very brief. 0.83. What is the ratio of the Value added (% of GDP) of South Africa in 2005 to that in 2008?
Give a very brief answer. 0.84. What is the ratio of the Value added (% of GDP) of Europe(developing only) in 2006 to that in 2007?
Keep it short and to the point. 1.13. What is the ratio of the Value added (% of GDP) in Indonesia in 2006 to that in 2007?
Provide a succinct answer. 0.95. What is the ratio of the Value added (% of GDP) in Paraguay in 2006 to that in 2007?
Keep it short and to the point. 0.9. What is the ratio of the Value added (% of GDP) of South Africa in 2006 to that in 2007?
Ensure brevity in your answer.  0.88. What is the ratio of the Value added (% of GDP) in Europe(developing only) in 2006 to that in 2008?
Make the answer very short. 1.12. What is the ratio of the Value added (% of GDP) in Indonesia in 2006 to that in 2008?
Ensure brevity in your answer.  0.9. What is the ratio of the Value added (% of GDP) of Paraguay in 2006 to that in 2008?
Make the answer very short. 0.81. What is the ratio of the Value added (% of GDP) in South Africa in 2006 to that in 2008?
Offer a very short reply. 0.82. What is the ratio of the Value added (% of GDP) in Europe(developing only) in 2007 to that in 2008?
Offer a terse response. 1. What is the ratio of the Value added (% of GDP) of Indonesia in 2007 to that in 2008?
Offer a very short reply. 0.95. What is the ratio of the Value added (% of GDP) in Paraguay in 2007 to that in 2008?
Keep it short and to the point. 0.9. What is the ratio of the Value added (% of GDP) in South Africa in 2007 to that in 2008?
Provide a succinct answer. 0.93. What is the difference between the highest and the second highest Value added (% of GDP) of Europe(developing only)?
Your response must be concise. 0.58. What is the difference between the highest and the second highest Value added (% of GDP) of Indonesia?
Provide a short and direct response. 0.27. What is the difference between the highest and the second highest Value added (% of GDP) in Paraguay?
Offer a terse response. 2.32. What is the difference between the highest and the second highest Value added (% of GDP) in South Africa?
Provide a succinct answer. 0.36. What is the difference between the highest and the lowest Value added (% of GDP) in Europe(developing only)?
Make the answer very short. 4.23. What is the difference between the highest and the lowest Value added (% of GDP) of Indonesia?
Make the answer very short. 2.48. What is the difference between the highest and the lowest Value added (% of GDP) of Paraguay?
Your answer should be very brief. 8.62. What is the difference between the highest and the lowest Value added (% of GDP) of South Africa?
Make the answer very short. 1.09. 